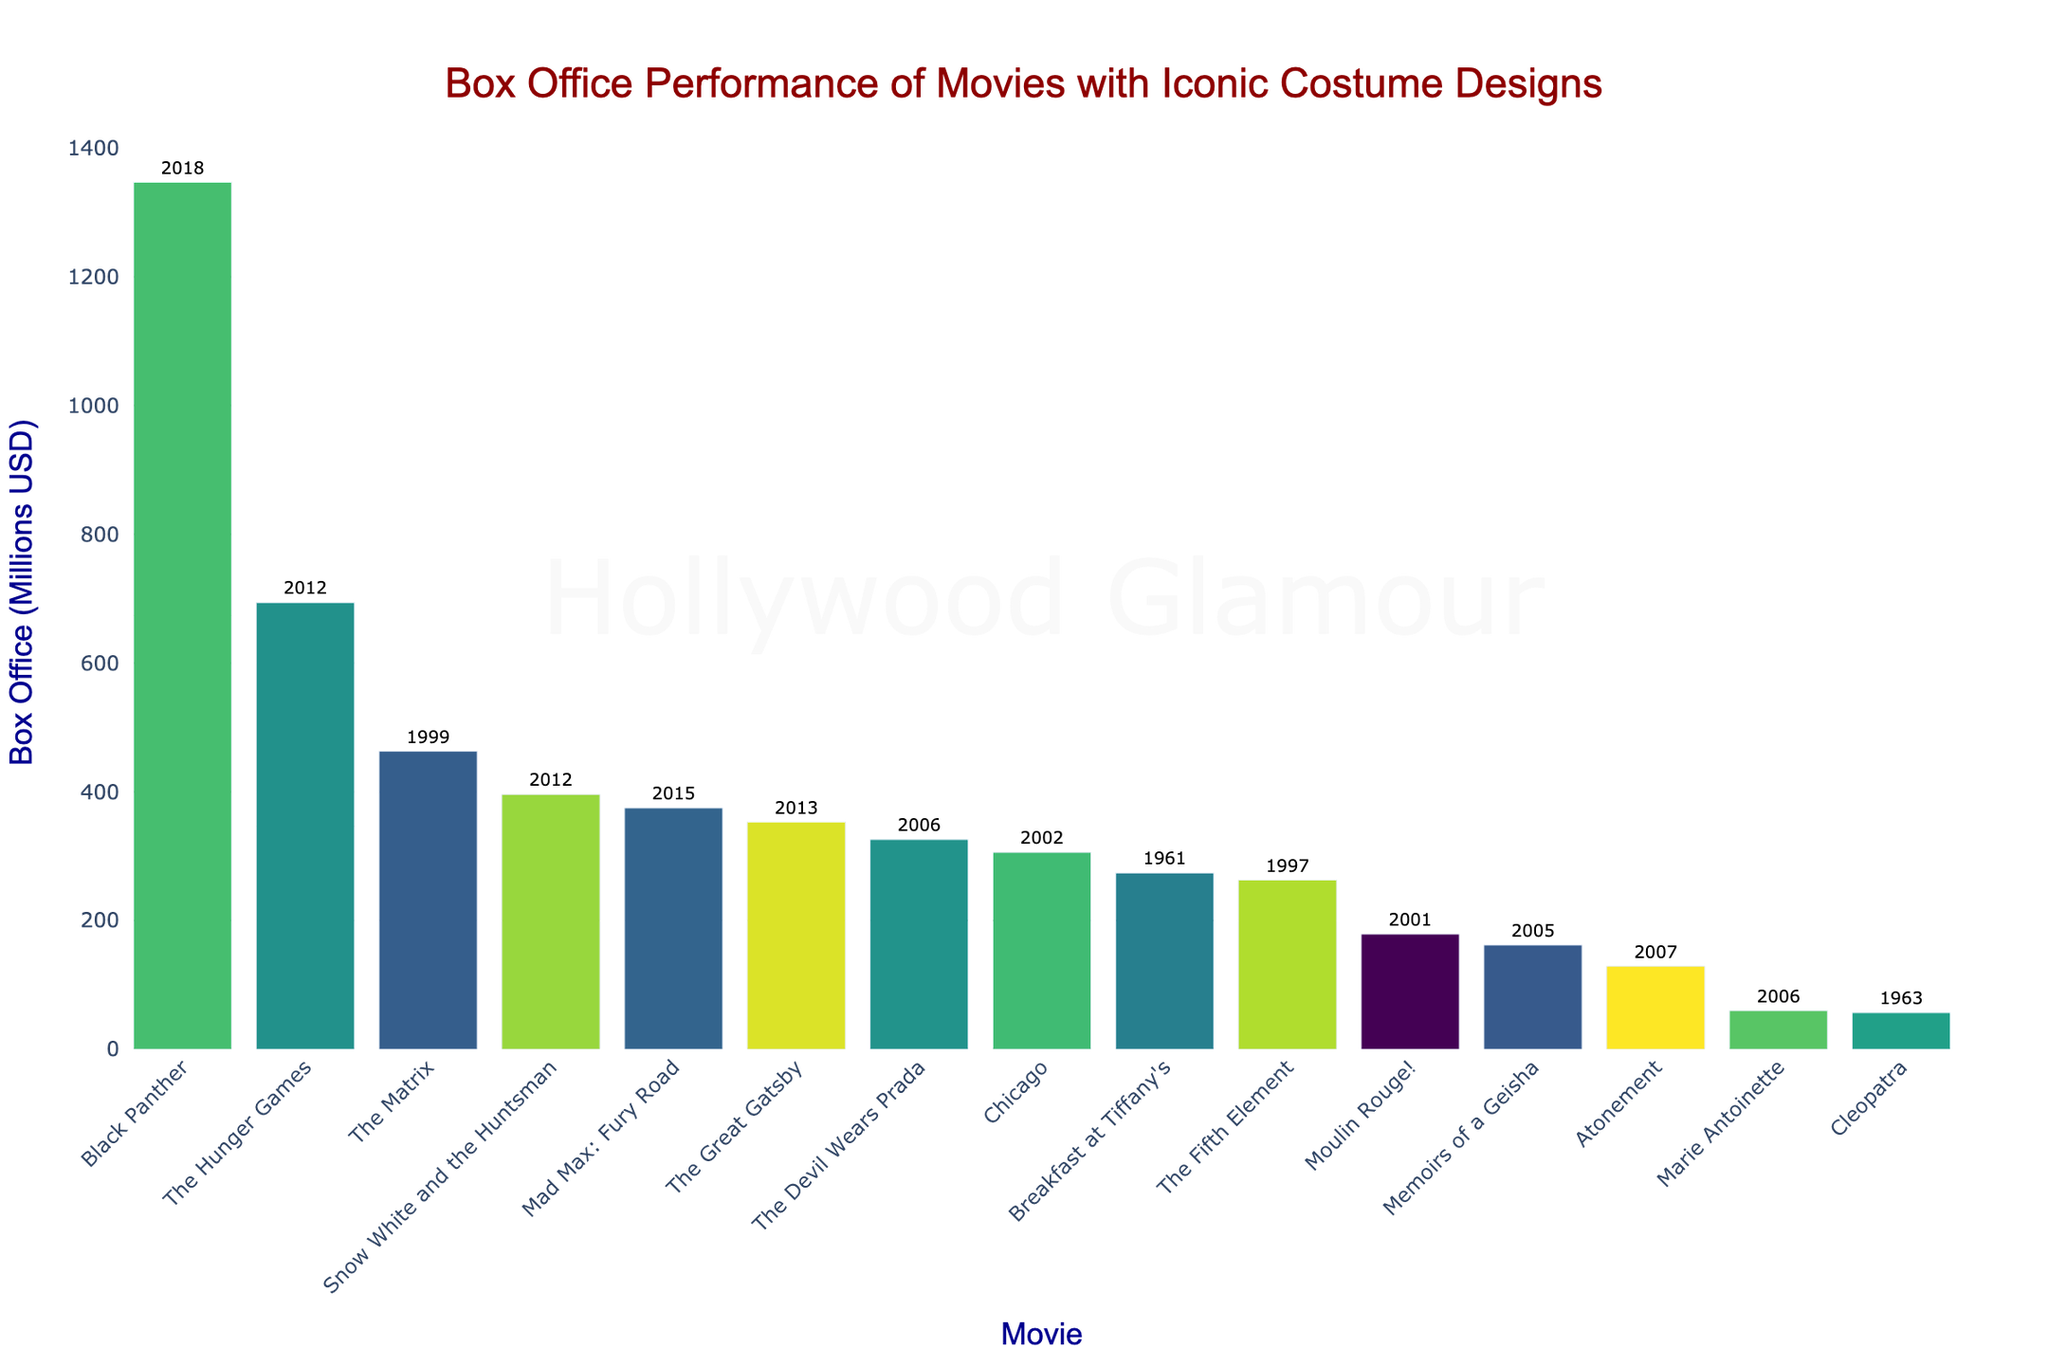Which movie had the highest box office performance? The bar chart shows "Black Panther" with the tallest bar, indicating the highest box office at $1347 million.
Answer: Black Panther Among the movies released in 2006, which one had a higher box office performance? The chart displays "The Devil Wears Prada" and "Marie Antoinette" from 2006. "The Devil Wears Prada" has a higher bar, reaching $326 million compared to "Marie Antoinette's" $60 million.
Answer: The Devil Wears Prada Which movie performed better at the box office: "Moulin Rouge!" or "Chicago"? Comparing the bars of "Moulin Rouge!" and "Chicago," "Chicago" has a higher bar, indicating it earned $306 million, whereas "Moulin Rouge!" earned $179 million.
Answer: Chicago What is the total box office of "The Great Gatsby" and "Mad Max: Fury Road"? The bar for "The Great Gatsby" is labeled $353 million, and "Mad Max: Fury Road" is labeled $375 million. Adding them together, $353 + $375 = $728 million.
Answer: $728 million Which movie had a lower box office performance: "Cleopatra" (1963) or "Marie Antoinette" (2006)? By comparing the bars for "Cleopatra" and "Marie Antoinette," "Cleopatra" has a lower bar, showing $57 million, whereas "Marie Antoinette" is $60 million.
Answer: Cleopatra How much more did "The Hunger Games" earn compared to "Memoirs of a Geisha"? The bar for "The Hunger Games" shows $694 million, and "Memoirs of a Geisha" shows $162 million. The difference is $694 - $162 = $532 million.
Answer: $532 million Which movie released in 2012 had a higher box office performance: "The Hunger Games" or "Snow White and the Huntsman"? Both movies are from 2012. The bar for "The Hunger Games" is higher, at $694 million, compared to "Snow White and the Huntsman's" $396 million.
Answer: The Hunger Games What is the average box office performance of all the movies listed? Summing the box office values: 326 + 274 + 1347 + 353 + 179 + 375 + 129 + 60 + 263 + 57 + 694 + 162 + 463 + 306 + 396 = 5384. There are 15 movies, so the average is 5384 / 15 ≈ 359.
Answer: 359 Which movie has the second highest box office performance? "The second tallest bar on the chart is for "The Hunger Games," labeled at $694 million, indicating it has the second highest box office performance after "Black Panther."
Answer: The Hunger Games What is the difference in box office performance between "The Fifth Element" and "The Matrix"? The bar for "The Fifth Element" shows $263 million, and "The Matrix" shows $463 million. The difference is $463 - $263 = $200 million.
Answer: $200 million 